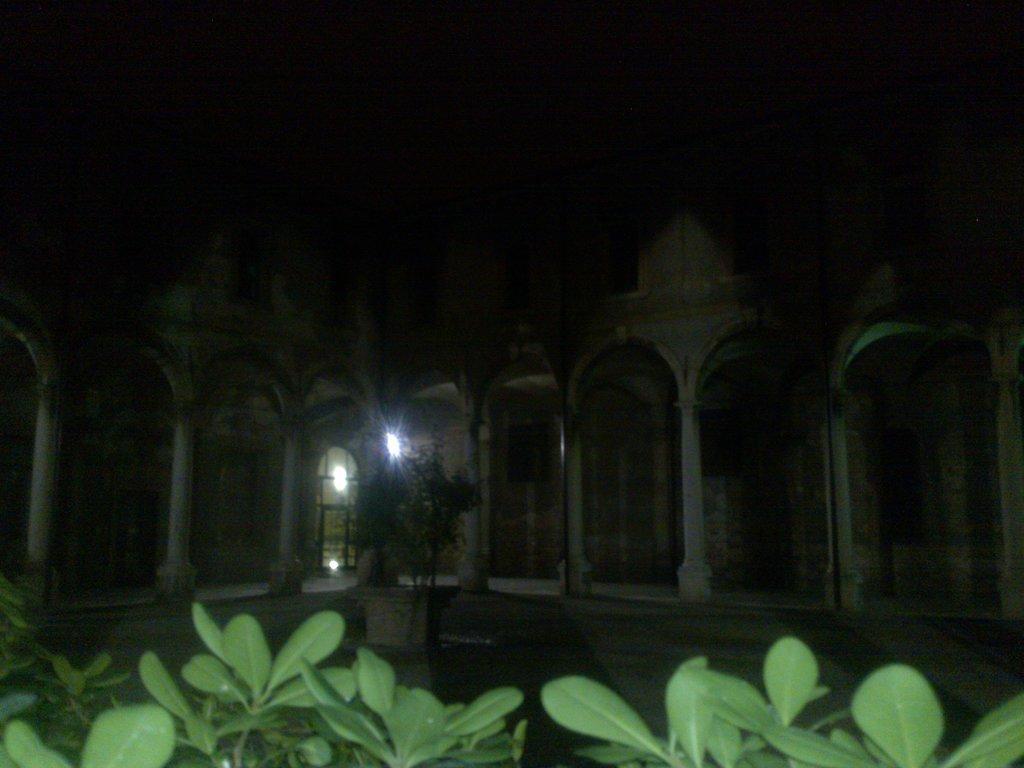Can you describe this image briefly? In this picture there are plants at the bottom side of the image and there is a building in the center of the image. 